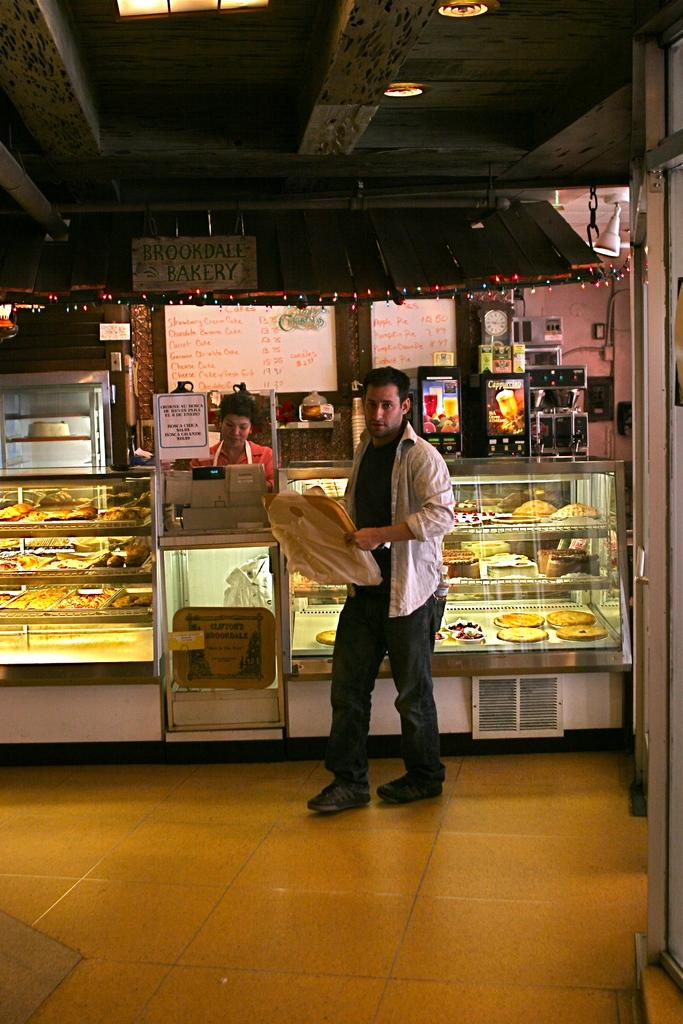What is the main subject of the image? There is a person standing in the image. What is the person holding in their hands? The person is holding an object in their hands. What else can be seen in the image besides the person? There are eatables visible in the image. Are there any other people in the image? Yes, there is another person in the image. What type of knot is being tied by the person in the image? There is no knot being tied in the image; the person is holding an object in their hands. What color is the gold item being held by the person in the image? There is no gold item present in the image; the person is holding an object, but its material is not specified. 